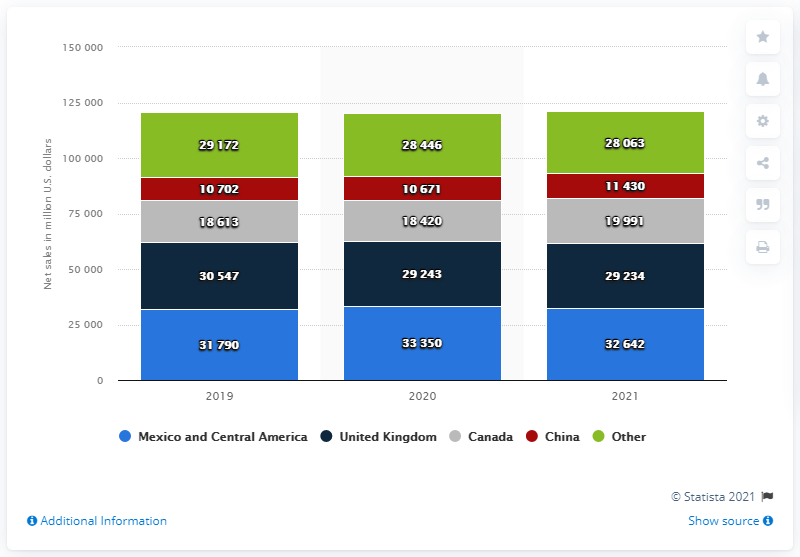Indicate a few pertinent items in this graphic. Walmart's net sales in Mexico and Central America in fiscal year 2021 were 32,642. Walmart International generated an estimated $292,340 in revenue in the United Kingdom in 2021. 